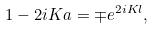Convert formula to latex. <formula><loc_0><loc_0><loc_500><loc_500>1 - 2 i K a = \mp e ^ { 2 i K l } ,</formula> 